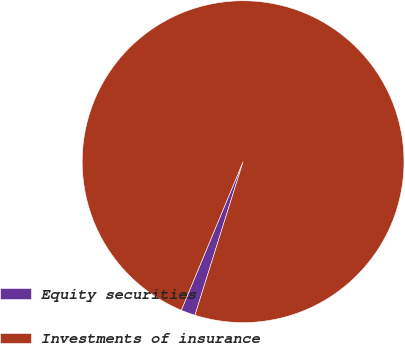Convert chart. <chart><loc_0><loc_0><loc_500><loc_500><pie_chart><fcel>Equity securities<fcel>Investments of insurance<nl><fcel>1.44%<fcel>98.56%<nl></chart> 